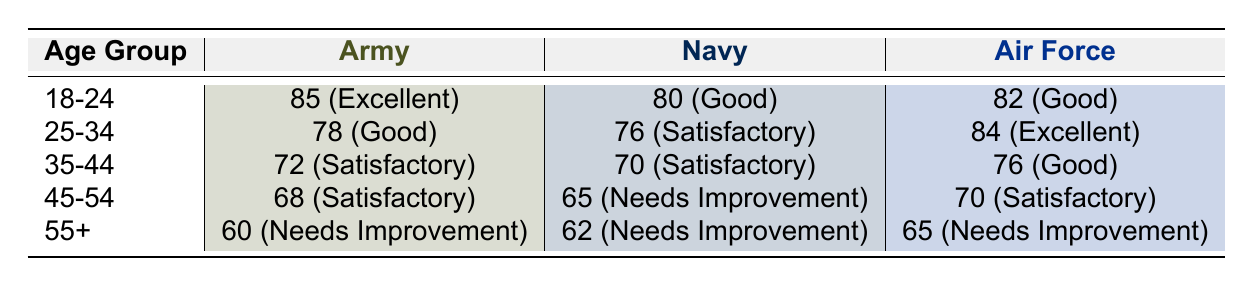What is the assessment score for the Air Force in the 25-34 age group? The table shows that in the 25-34 age group, the assessment score for the Air Force is 84.
Answer: 84 Which service branch has the highest fitness level in the 18-24 age group? According to the table, the Army has the highest fitness level at "Excellent" with a score of 85 in the 18-24 age group.
Answer: Army Is the average assessment score for the Navy across all age groups greater than 70? To calculate the average for the Navy, we sum the scores: 80 + 76 + 70 + 65 + 62 = 353. Dividing by the number of age groups (5) gives an average of 353 / 5 = 70.6, which is greater than 70.
Answer: Yes What is the difference in assessment scores between the Army and Air Force for the 45-54 age group? The assessment score for the Army in the 45-54 age group is 68 and for the Air Force, it is 70. The difference is 70 - 68 = 2.
Answer: 2 In which age group does the Navy have a fitness level of "Needs Improvement"? The table indicates that the Navy has a fitness level of "Needs Improvement" in the 45-54 and 55+ age groups.
Answer: 45-54 and 55+ What is the total assessment score for all branches in the 35-44 age group? The scores for the 35-44 age group are 72 (Army) + 70 (Navy) + 76 (Air Force) = 218.
Answer: 218 Is it true that all branches score below 70 in the 55+ age group? The table shows that in the 55+ age group, the Army scored 60, the Navy scored 62, and the Air Force scored 65, which are all below 70.
Answer: Yes What is the average assessment score for the Army across all age groups? The Army's scores are 85 (18-24) + 78 (25-34) + 72 (35-44) + 68 (45-54) + 60 (55+) = 363. Dividing by the number of age groups (5) gives an average of 363 / 5 = 72.6.
Answer: 72.6 